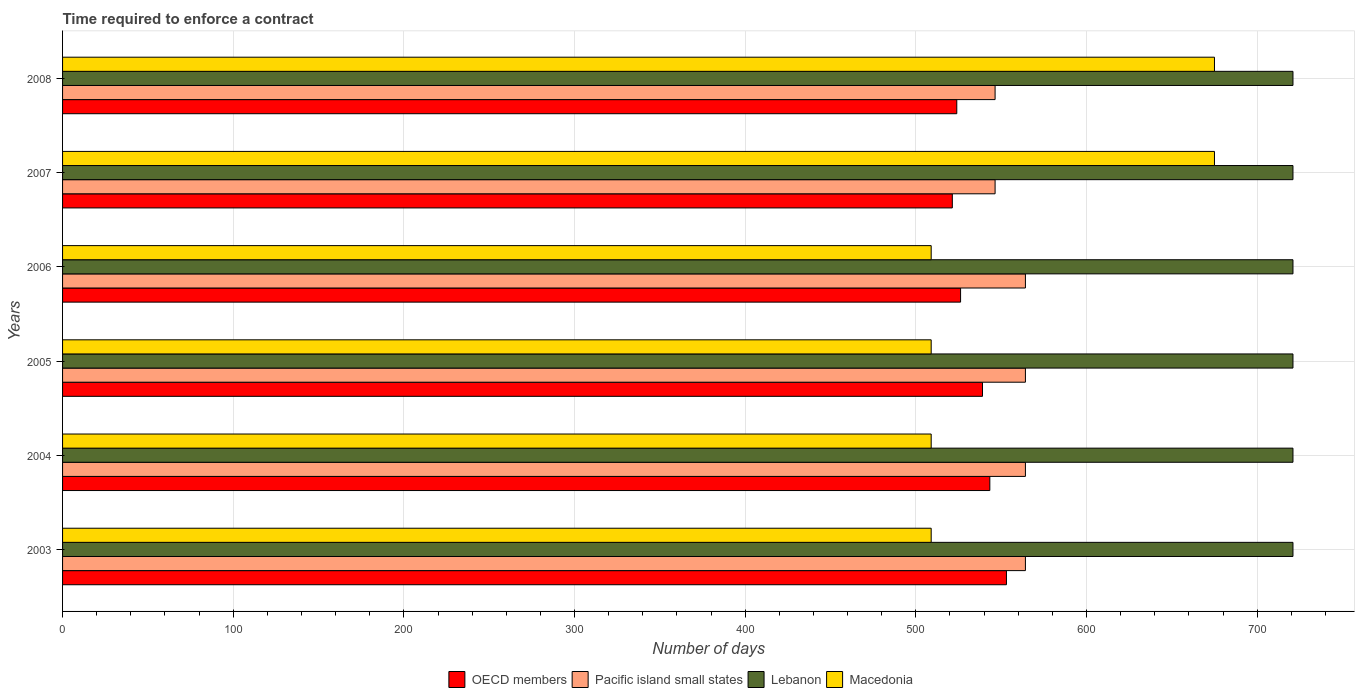How many different coloured bars are there?
Provide a succinct answer. 4. How many groups of bars are there?
Provide a succinct answer. 6. What is the label of the 3rd group of bars from the top?
Your answer should be very brief. 2006. In how many cases, is the number of bars for a given year not equal to the number of legend labels?
Keep it short and to the point. 0. What is the number of days required to enforce a contract in Pacific island small states in 2006?
Offer a very short reply. 564.22. Across all years, what is the maximum number of days required to enforce a contract in OECD members?
Offer a terse response. 553.1. Across all years, what is the minimum number of days required to enforce a contract in Lebanon?
Your response must be concise. 721. In which year was the number of days required to enforce a contract in Macedonia maximum?
Your response must be concise. 2007. In which year was the number of days required to enforce a contract in Pacific island small states minimum?
Offer a terse response. 2007. What is the total number of days required to enforce a contract in OECD members in the graph?
Ensure brevity in your answer.  3207.15. What is the difference between the number of days required to enforce a contract in Lebanon in 2007 and that in 2008?
Offer a very short reply. 0. What is the average number of days required to enforce a contract in Pacific island small states per year?
Provide a short and direct response. 558.3. In the year 2005, what is the difference between the number of days required to enforce a contract in Pacific island small states and number of days required to enforce a contract in Macedonia?
Make the answer very short. 55.22. What is the difference between the highest and the lowest number of days required to enforce a contract in Pacific island small states?
Keep it short and to the point. 17.78. Is it the case that in every year, the sum of the number of days required to enforce a contract in OECD members and number of days required to enforce a contract in Pacific island small states is greater than the sum of number of days required to enforce a contract in Lebanon and number of days required to enforce a contract in Macedonia?
Give a very brief answer. No. What does the 4th bar from the top in 2005 represents?
Your answer should be compact. OECD members. What does the 1st bar from the bottom in 2006 represents?
Provide a short and direct response. OECD members. Is it the case that in every year, the sum of the number of days required to enforce a contract in OECD members and number of days required to enforce a contract in Pacific island small states is greater than the number of days required to enforce a contract in Lebanon?
Keep it short and to the point. Yes. How many bars are there?
Your response must be concise. 24. Are all the bars in the graph horizontal?
Keep it short and to the point. Yes. What is the difference between two consecutive major ticks on the X-axis?
Make the answer very short. 100. Are the values on the major ticks of X-axis written in scientific E-notation?
Your answer should be very brief. No. Does the graph contain any zero values?
Provide a succinct answer. No. Where does the legend appear in the graph?
Keep it short and to the point. Bottom center. What is the title of the graph?
Offer a terse response. Time required to enforce a contract. What is the label or title of the X-axis?
Offer a terse response. Number of days. What is the label or title of the Y-axis?
Provide a short and direct response. Years. What is the Number of days in OECD members in 2003?
Your response must be concise. 553.1. What is the Number of days of Pacific island small states in 2003?
Offer a very short reply. 564.22. What is the Number of days in Lebanon in 2003?
Your answer should be very brief. 721. What is the Number of days of Macedonia in 2003?
Offer a terse response. 509. What is the Number of days of OECD members in 2004?
Keep it short and to the point. 543.37. What is the Number of days in Pacific island small states in 2004?
Provide a succinct answer. 564.22. What is the Number of days of Lebanon in 2004?
Keep it short and to the point. 721. What is the Number of days of Macedonia in 2004?
Ensure brevity in your answer.  509. What is the Number of days in OECD members in 2005?
Your response must be concise. 539.07. What is the Number of days in Pacific island small states in 2005?
Your answer should be compact. 564.22. What is the Number of days of Lebanon in 2005?
Give a very brief answer. 721. What is the Number of days of Macedonia in 2005?
Your response must be concise. 509. What is the Number of days of OECD members in 2006?
Keep it short and to the point. 526.23. What is the Number of days of Pacific island small states in 2006?
Your answer should be compact. 564.22. What is the Number of days of Lebanon in 2006?
Keep it short and to the point. 721. What is the Number of days in Macedonia in 2006?
Offer a terse response. 509. What is the Number of days in OECD members in 2007?
Give a very brief answer. 521.39. What is the Number of days in Pacific island small states in 2007?
Provide a succinct answer. 546.44. What is the Number of days of Lebanon in 2007?
Provide a succinct answer. 721. What is the Number of days in Macedonia in 2007?
Offer a terse response. 675. What is the Number of days in OECD members in 2008?
Your answer should be very brief. 524. What is the Number of days of Pacific island small states in 2008?
Offer a very short reply. 546.44. What is the Number of days in Lebanon in 2008?
Your response must be concise. 721. What is the Number of days in Macedonia in 2008?
Offer a terse response. 675. Across all years, what is the maximum Number of days of OECD members?
Offer a terse response. 553.1. Across all years, what is the maximum Number of days in Pacific island small states?
Ensure brevity in your answer.  564.22. Across all years, what is the maximum Number of days of Lebanon?
Provide a short and direct response. 721. Across all years, what is the maximum Number of days in Macedonia?
Offer a very short reply. 675. Across all years, what is the minimum Number of days of OECD members?
Keep it short and to the point. 521.39. Across all years, what is the minimum Number of days of Pacific island small states?
Give a very brief answer. 546.44. Across all years, what is the minimum Number of days of Lebanon?
Offer a terse response. 721. Across all years, what is the minimum Number of days of Macedonia?
Your response must be concise. 509. What is the total Number of days of OECD members in the graph?
Provide a succinct answer. 3207.15. What is the total Number of days of Pacific island small states in the graph?
Offer a very short reply. 3349.78. What is the total Number of days in Lebanon in the graph?
Make the answer very short. 4326. What is the total Number of days in Macedonia in the graph?
Make the answer very short. 3386. What is the difference between the Number of days of OECD members in 2003 and that in 2004?
Your answer should be very brief. 9.74. What is the difference between the Number of days in Pacific island small states in 2003 and that in 2004?
Provide a succinct answer. 0. What is the difference between the Number of days in Lebanon in 2003 and that in 2004?
Your response must be concise. 0. What is the difference between the Number of days of OECD members in 2003 and that in 2005?
Offer a very short reply. 14.04. What is the difference between the Number of days in Macedonia in 2003 and that in 2005?
Ensure brevity in your answer.  0. What is the difference between the Number of days of OECD members in 2003 and that in 2006?
Offer a terse response. 26.88. What is the difference between the Number of days in Pacific island small states in 2003 and that in 2006?
Provide a short and direct response. 0. What is the difference between the Number of days of Macedonia in 2003 and that in 2006?
Your answer should be very brief. 0. What is the difference between the Number of days in OECD members in 2003 and that in 2007?
Give a very brief answer. 31.72. What is the difference between the Number of days in Pacific island small states in 2003 and that in 2007?
Give a very brief answer. 17.78. What is the difference between the Number of days of Macedonia in 2003 and that in 2007?
Provide a succinct answer. -166. What is the difference between the Number of days of OECD members in 2003 and that in 2008?
Offer a terse response. 29.1. What is the difference between the Number of days in Pacific island small states in 2003 and that in 2008?
Your answer should be very brief. 17.78. What is the difference between the Number of days of Macedonia in 2003 and that in 2008?
Offer a terse response. -166. What is the difference between the Number of days of Macedonia in 2004 and that in 2005?
Make the answer very short. 0. What is the difference between the Number of days in OECD members in 2004 and that in 2006?
Offer a very short reply. 17.14. What is the difference between the Number of days of Pacific island small states in 2004 and that in 2006?
Keep it short and to the point. 0. What is the difference between the Number of days in OECD members in 2004 and that in 2007?
Your answer should be compact. 21.98. What is the difference between the Number of days of Pacific island small states in 2004 and that in 2007?
Ensure brevity in your answer.  17.78. What is the difference between the Number of days of Macedonia in 2004 and that in 2007?
Give a very brief answer. -166. What is the difference between the Number of days of OECD members in 2004 and that in 2008?
Give a very brief answer. 19.37. What is the difference between the Number of days in Pacific island small states in 2004 and that in 2008?
Give a very brief answer. 17.78. What is the difference between the Number of days of Lebanon in 2004 and that in 2008?
Provide a short and direct response. 0. What is the difference between the Number of days of Macedonia in 2004 and that in 2008?
Ensure brevity in your answer.  -166. What is the difference between the Number of days in OECD members in 2005 and that in 2006?
Offer a very short reply. 12.84. What is the difference between the Number of days of OECD members in 2005 and that in 2007?
Make the answer very short. 17.68. What is the difference between the Number of days in Pacific island small states in 2005 and that in 2007?
Ensure brevity in your answer.  17.78. What is the difference between the Number of days in Macedonia in 2005 and that in 2007?
Keep it short and to the point. -166. What is the difference between the Number of days of OECD members in 2005 and that in 2008?
Keep it short and to the point. 15.07. What is the difference between the Number of days of Pacific island small states in 2005 and that in 2008?
Make the answer very short. 17.78. What is the difference between the Number of days in Macedonia in 2005 and that in 2008?
Offer a terse response. -166. What is the difference between the Number of days in OECD members in 2006 and that in 2007?
Offer a very short reply. 4.84. What is the difference between the Number of days in Pacific island small states in 2006 and that in 2007?
Give a very brief answer. 17.78. What is the difference between the Number of days of Lebanon in 2006 and that in 2007?
Your answer should be compact. 0. What is the difference between the Number of days in Macedonia in 2006 and that in 2007?
Provide a succinct answer. -166. What is the difference between the Number of days in OECD members in 2006 and that in 2008?
Offer a very short reply. 2.23. What is the difference between the Number of days of Pacific island small states in 2006 and that in 2008?
Keep it short and to the point. 17.78. What is the difference between the Number of days in Lebanon in 2006 and that in 2008?
Offer a very short reply. 0. What is the difference between the Number of days of Macedonia in 2006 and that in 2008?
Provide a succinct answer. -166. What is the difference between the Number of days in OECD members in 2007 and that in 2008?
Give a very brief answer. -2.61. What is the difference between the Number of days of Pacific island small states in 2007 and that in 2008?
Offer a terse response. 0. What is the difference between the Number of days in Macedonia in 2007 and that in 2008?
Make the answer very short. 0. What is the difference between the Number of days in OECD members in 2003 and the Number of days in Pacific island small states in 2004?
Provide a succinct answer. -11.12. What is the difference between the Number of days in OECD members in 2003 and the Number of days in Lebanon in 2004?
Your answer should be compact. -167.9. What is the difference between the Number of days of OECD members in 2003 and the Number of days of Macedonia in 2004?
Give a very brief answer. 44.1. What is the difference between the Number of days of Pacific island small states in 2003 and the Number of days of Lebanon in 2004?
Ensure brevity in your answer.  -156.78. What is the difference between the Number of days in Pacific island small states in 2003 and the Number of days in Macedonia in 2004?
Make the answer very short. 55.22. What is the difference between the Number of days in Lebanon in 2003 and the Number of days in Macedonia in 2004?
Your answer should be very brief. 212. What is the difference between the Number of days in OECD members in 2003 and the Number of days in Pacific island small states in 2005?
Your response must be concise. -11.12. What is the difference between the Number of days of OECD members in 2003 and the Number of days of Lebanon in 2005?
Keep it short and to the point. -167.9. What is the difference between the Number of days of OECD members in 2003 and the Number of days of Macedonia in 2005?
Offer a terse response. 44.1. What is the difference between the Number of days of Pacific island small states in 2003 and the Number of days of Lebanon in 2005?
Provide a short and direct response. -156.78. What is the difference between the Number of days of Pacific island small states in 2003 and the Number of days of Macedonia in 2005?
Ensure brevity in your answer.  55.22. What is the difference between the Number of days in Lebanon in 2003 and the Number of days in Macedonia in 2005?
Your response must be concise. 212. What is the difference between the Number of days of OECD members in 2003 and the Number of days of Pacific island small states in 2006?
Make the answer very short. -11.12. What is the difference between the Number of days of OECD members in 2003 and the Number of days of Lebanon in 2006?
Make the answer very short. -167.9. What is the difference between the Number of days of OECD members in 2003 and the Number of days of Macedonia in 2006?
Offer a terse response. 44.1. What is the difference between the Number of days in Pacific island small states in 2003 and the Number of days in Lebanon in 2006?
Offer a very short reply. -156.78. What is the difference between the Number of days of Pacific island small states in 2003 and the Number of days of Macedonia in 2006?
Provide a short and direct response. 55.22. What is the difference between the Number of days in Lebanon in 2003 and the Number of days in Macedonia in 2006?
Provide a short and direct response. 212. What is the difference between the Number of days of OECD members in 2003 and the Number of days of Pacific island small states in 2007?
Ensure brevity in your answer.  6.66. What is the difference between the Number of days in OECD members in 2003 and the Number of days in Lebanon in 2007?
Your answer should be compact. -167.9. What is the difference between the Number of days in OECD members in 2003 and the Number of days in Macedonia in 2007?
Your answer should be compact. -121.9. What is the difference between the Number of days of Pacific island small states in 2003 and the Number of days of Lebanon in 2007?
Provide a short and direct response. -156.78. What is the difference between the Number of days of Pacific island small states in 2003 and the Number of days of Macedonia in 2007?
Keep it short and to the point. -110.78. What is the difference between the Number of days of OECD members in 2003 and the Number of days of Pacific island small states in 2008?
Provide a succinct answer. 6.66. What is the difference between the Number of days of OECD members in 2003 and the Number of days of Lebanon in 2008?
Offer a very short reply. -167.9. What is the difference between the Number of days of OECD members in 2003 and the Number of days of Macedonia in 2008?
Offer a terse response. -121.9. What is the difference between the Number of days of Pacific island small states in 2003 and the Number of days of Lebanon in 2008?
Your response must be concise. -156.78. What is the difference between the Number of days in Pacific island small states in 2003 and the Number of days in Macedonia in 2008?
Offer a terse response. -110.78. What is the difference between the Number of days of OECD members in 2004 and the Number of days of Pacific island small states in 2005?
Ensure brevity in your answer.  -20.86. What is the difference between the Number of days in OECD members in 2004 and the Number of days in Lebanon in 2005?
Make the answer very short. -177.63. What is the difference between the Number of days of OECD members in 2004 and the Number of days of Macedonia in 2005?
Your answer should be very brief. 34.37. What is the difference between the Number of days of Pacific island small states in 2004 and the Number of days of Lebanon in 2005?
Offer a terse response. -156.78. What is the difference between the Number of days of Pacific island small states in 2004 and the Number of days of Macedonia in 2005?
Offer a terse response. 55.22. What is the difference between the Number of days in Lebanon in 2004 and the Number of days in Macedonia in 2005?
Provide a succinct answer. 212. What is the difference between the Number of days in OECD members in 2004 and the Number of days in Pacific island small states in 2006?
Ensure brevity in your answer.  -20.86. What is the difference between the Number of days in OECD members in 2004 and the Number of days in Lebanon in 2006?
Your answer should be compact. -177.63. What is the difference between the Number of days of OECD members in 2004 and the Number of days of Macedonia in 2006?
Provide a short and direct response. 34.37. What is the difference between the Number of days of Pacific island small states in 2004 and the Number of days of Lebanon in 2006?
Make the answer very short. -156.78. What is the difference between the Number of days in Pacific island small states in 2004 and the Number of days in Macedonia in 2006?
Provide a short and direct response. 55.22. What is the difference between the Number of days of Lebanon in 2004 and the Number of days of Macedonia in 2006?
Your answer should be compact. 212. What is the difference between the Number of days in OECD members in 2004 and the Number of days in Pacific island small states in 2007?
Keep it short and to the point. -3.08. What is the difference between the Number of days in OECD members in 2004 and the Number of days in Lebanon in 2007?
Ensure brevity in your answer.  -177.63. What is the difference between the Number of days of OECD members in 2004 and the Number of days of Macedonia in 2007?
Make the answer very short. -131.63. What is the difference between the Number of days of Pacific island small states in 2004 and the Number of days of Lebanon in 2007?
Make the answer very short. -156.78. What is the difference between the Number of days of Pacific island small states in 2004 and the Number of days of Macedonia in 2007?
Offer a very short reply. -110.78. What is the difference between the Number of days of Lebanon in 2004 and the Number of days of Macedonia in 2007?
Your answer should be very brief. 46. What is the difference between the Number of days in OECD members in 2004 and the Number of days in Pacific island small states in 2008?
Keep it short and to the point. -3.08. What is the difference between the Number of days of OECD members in 2004 and the Number of days of Lebanon in 2008?
Provide a succinct answer. -177.63. What is the difference between the Number of days in OECD members in 2004 and the Number of days in Macedonia in 2008?
Offer a terse response. -131.63. What is the difference between the Number of days of Pacific island small states in 2004 and the Number of days of Lebanon in 2008?
Your answer should be very brief. -156.78. What is the difference between the Number of days of Pacific island small states in 2004 and the Number of days of Macedonia in 2008?
Your answer should be very brief. -110.78. What is the difference between the Number of days of OECD members in 2005 and the Number of days of Pacific island small states in 2006?
Provide a succinct answer. -25.16. What is the difference between the Number of days of OECD members in 2005 and the Number of days of Lebanon in 2006?
Provide a short and direct response. -181.93. What is the difference between the Number of days of OECD members in 2005 and the Number of days of Macedonia in 2006?
Provide a succinct answer. 30.07. What is the difference between the Number of days in Pacific island small states in 2005 and the Number of days in Lebanon in 2006?
Keep it short and to the point. -156.78. What is the difference between the Number of days in Pacific island small states in 2005 and the Number of days in Macedonia in 2006?
Give a very brief answer. 55.22. What is the difference between the Number of days in Lebanon in 2005 and the Number of days in Macedonia in 2006?
Your response must be concise. 212. What is the difference between the Number of days in OECD members in 2005 and the Number of days in Pacific island small states in 2007?
Provide a short and direct response. -7.38. What is the difference between the Number of days in OECD members in 2005 and the Number of days in Lebanon in 2007?
Your response must be concise. -181.93. What is the difference between the Number of days in OECD members in 2005 and the Number of days in Macedonia in 2007?
Offer a terse response. -135.93. What is the difference between the Number of days in Pacific island small states in 2005 and the Number of days in Lebanon in 2007?
Provide a short and direct response. -156.78. What is the difference between the Number of days in Pacific island small states in 2005 and the Number of days in Macedonia in 2007?
Give a very brief answer. -110.78. What is the difference between the Number of days of OECD members in 2005 and the Number of days of Pacific island small states in 2008?
Keep it short and to the point. -7.38. What is the difference between the Number of days of OECD members in 2005 and the Number of days of Lebanon in 2008?
Your answer should be compact. -181.93. What is the difference between the Number of days in OECD members in 2005 and the Number of days in Macedonia in 2008?
Ensure brevity in your answer.  -135.93. What is the difference between the Number of days of Pacific island small states in 2005 and the Number of days of Lebanon in 2008?
Keep it short and to the point. -156.78. What is the difference between the Number of days of Pacific island small states in 2005 and the Number of days of Macedonia in 2008?
Provide a short and direct response. -110.78. What is the difference between the Number of days of Lebanon in 2005 and the Number of days of Macedonia in 2008?
Provide a short and direct response. 46. What is the difference between the Number of days in OECD members in 2006 and the Number of days in Pacific island small states in 2007?
Offer a terse response. -20.22. What is the difference between the Number of days of OECD members in 2006 and the Number of days of Lebanon in 2007?
Provide a short and direct response. -194.77. What is the difference between the Number of days in OECD members in 2006 and the Number of days in Macedonia in 2007?
Provide a short and direct response. -148.77. What is the difference between the Number of days of Pacific island small states in 2006 and the Number of days of Lebanon in 2007?
Offer a very short reply. -156.78. What is the difference between the Number of days of Pacific island small states in 2006 and the Number of days of Macedonia in 2007?
Your answer should be compact. -110.78. What is the difference between the Number of days of Lebanon in 2006 and the Number of days of Macedonia in 2007?
Give a very brief answer. 46. What is the difference between the Number of days of OECD members in 2006 and the Number of days of Pacific island small states in 2008?
Provide a succinct answer. -20.22. What is the difference between the Number of days in OECD members in 2006 and the Number of days in Lebanon in 2008?
Your response must be concise. -194.77. What is the difference between the Number of days in OECD members in 2006 and the Number of days in Macedonia in 2008?
Offer a terse response. -148.77. What is the difference between the Number of days in Pacific island small states in 2006 and the Number of days in Lebanon in 2008?
Provide a short and direct response. -156.78. What is the difference between the Number of days of Pacific island small states in 2006 and the Number of days of Macedonia in 2008?
Ensure brevity in your answer.  -110.78. What is the difference between the Number of days in OECD members in 2007 and the Number of days in Pacific island small states in 2008?
Your answer should be very brief. -25.06. What is the difference between the Number of days of OECD members in 2007 and the Number of days of Lebanon in 2008?
Provide a short and direct response. -199.61. What is the difference between the Number of days in OECD members in 2007 and the Number of days in Macedonia in 2008?
Offer a terse response. -153.61. What is the difference between the Number of days in Pacific island small states in 2007 and the Number of days in Lebanon in 2008?
Your response must be concise. -174.56. What is the difference between the Number of days in Pacific island small states in 2007 and the Number of days in Macedonia in 2008?
Offer a very short reply. -128.56. What is the difference between the Number of days in Lebanon in 2007 and the Number of days in Macedonia in 2008?
Make the answer very short. 46. What is the average Number of days in OECD members per year?
Your answer should be very brief. 534.52. What is the average Number of days of Pacific island small states per year?
Make the answer very short. 558.3. What is the average Number of days in Lebanon per year?
Offer a very short reply. 721. What is the average Number of days in Macedonia per year?
Provide a short and direct response. 564.33. In the year 2003, what is the difference between the Number of days of OECD members and Number of days of Pacific island small states?
Your answer should be compact. -11.12. In the year 2003, what is the difference between the Number of days of OECD members and Number of days of Lebanon?
Make the answer very short. -167.9. In the year 2003, what is the difference between the Number of days of OECD members and Number of days of Macedonia?
Offer a very short reply. 44.1. In the year 2003, what is the difference between the Number of days in Pacific island small states and Number of days in Lebanon?
Your answer should be compact. -156.78. In the year 2003, what is the difference between the Number of days in Pacific island small states and Number of days in Macedonia?
Provide a succinct answer. 55.22. In the year 2003, what is the difference between the Number of days of Lebanon and Number of days of Macedonia?
Give a very brief answer. 212. In the year 2004, what is the difference between the Number of days in OECD members and Number of days in Pacific island small states?
Your answer should be very brief. -20.86. In the year 2004, what is the difference between the Number of days in OECD members and Number of days in Lebanon?
Offer a terse response. -177.63. In the year 2004, what is the difference between the Number of days of OECD members and Number of days of Macedonia?
Your answer should be compact. 34.37. In the year 2004, what is the difference between the Number of days in Pacific island small states and Number of days in Lebanon?
Your response must be concise. -156.78. In the year 2004, what is the difference between the Number of days in Pacific island small states and Number of days in Macedonia?
Give a very brief answer. 55.22. In the year 2004, what is the difference between the Number of days in Lebanon and Number of days in Macedonia?
Keep it short and to the point. 212. In the year 2005, what is the difference between the Number of days in OECD members and Number of days in Pacific island small states?
Give a very brief answer. -25.16. In the year 2005, what is the difference between the Number of days of OECD members and Number of days of Lebanon?
Ensure brevity in your answer.  -181.93. In the year 2005, what is the difference between the Number of days in OECD members and Number of days in Macedonia?
Your answer should be very brief. 30.07. In the year 2005, what is the difference between the Number of days of Pacific island small states and Number of days of Lebanon?
Give a very brief answer. -156.78. In the year 2005, what is the difference between the Number of days of Pacific island small states and Number of days of Macedonia?
Ensure brevity in your answer.  55.22. In the year 2005, what is the difference between the Number of days in Lebanon and Number of days in Macedonia?
Provide a succinct answer. 212. In the year 2006, what is the difference between the Number of days of OECD members and Number of days of Pacific island small states?
Your answer should be compact. -38. In the year 2006, what is the difference between the Number of days of OECD members and Number of days of Lebanon?
Give a very brief answer. -194.77. In the year 2006, what is the difference between the Number of days in OECD members and Number of days in Macedonia?
Your answer should be very brief. 17.23. In the year 2006, what is the difference between the Number of days of Pacific island small states and Number of days of Lebanon?
Keep it short and to the point. -156.78. In the year 2006, what is the difference between the Number of days in Pacific island small states and Number of days in Macedonia?
Provide a succinct answer. 55.22. In the year 2006, what is the difference between the Number of days of Lebanon and Number of days of Macedonia?
Offer a terse response. 212. In the year 2007, what is the difference between the Number of days in OECD members and Number of days in Pacific island small states?
Offer a terse response. -25.06. In the year 2007, what is the difference between the Number of days in OECD members and Number of days in Lebanon?
Provide a succinct answer. -199.61. In the year 2007, what is the difference between the Number of days of OECD members and Number of days of Macedonia?
Your answer should be very brief. -153.61. In the year 2007, what is the difference between the Number of days of Pacific island small states and Number of days of Lebanon?
Give a very brief answer. -174.56. In the year 2007, what is the difference between the Number of days in Pacific island small states and Number of days in Macedonia?
Offer a terse response. -128.56. In the year 2007, what is the difference between the Number of days of Lebanon and Number of days of Macedonia?
Make the answer very short. 46. In the year 2008, what is the difference between the Number of days of OECD members and Number of days of Pacific island small states?
Give a very brief answer. -22.44. In the year 2008, what is the difference between the Number of days in OECD members and Number of days in Lebanon?
Offer a terse response. -197. In the year 2008, what is the difference between the Number of days of OECD members and Number of days of Macedonia?
Ensure brevity in your answer.  -151. In the year 2008, what is the difference between the Number of days in Pacific island small states and Number of days in Lebanon?
Offer a terse response. -174.56. In the year 2008, what is the difference between the Number of days of Pacific island small states and Number of days of Macedonia?
Offer a very short reply. -128.56. In the year 2008, what is the difference between the Number of days of Lebanon and Number of days of Macedonia?
Your answer should be compact. 46. What is the ratio of the Number of days of OECD members in 2003 to that in 2004?
Make the answer very short. 1.02. What is the ratio of the Number of days in Pacific island small states in 2003 to that in 2004?
Give a very brief answer. 1. What is the ratio of the Number of days of Lebanon in 2003 to that in 2004?
Provide a short and direct response. 1. What is the ratio of the Number of days of Macedonia in 2003 to that in 2004?
Give a very brief answer. 1. What is the ratio of the Number of days in OECD members in 2003 to that in 2005?
Make the answer very short. 1.03. What is the ratio of the Number of days of Macedonia in 2003 to that in 2005?
Make the answer very short. 1. What is the ratio of the Number of days of OECD members in 2003 to that in 2006?
Your answer should be very brief. 1.05. What is the ratio of the Number of days of Macedonia in 2003 to that in 2006?
Your answer should be compact. 1. What is the ratio of the Number of days in OECD members in 2003 to that in 2007?
Ensure brevity in your answer.  1.06. What is the ratio of the Number of days in Pacific island small states in 2003 to that in 2007?
Your answer should be compact. 1.03. What is the ratio of the Number of days in Lebanon in 2003 to that in 2007?
Your response must be concise. 1. What is the ratio of the Number of days of Macedonia in 2003 to that in 2007?
Give a very brief answer. 0.75. What is the ratio of the Number of days in OECD members in 2003 to that in 2008?
Your answer should be very brief. 1.06. What is the ratio of the Number of days of Pacific island small states in 2003 to that in 2008?
Keep it short and to the point. 1.03. What is the ratio of the Number of days in Macedonia in 2003 to that in 2008?
Your response must be concise. 0.75. What is the ratio of the Number of days in Pacific island small states in 2004 to that in 2005?
Make the answer very short. 1. What is the ratio of the Number of days in OECD members in 2004 to that in 2006?
Your response must be concise. 1.03. What is the ratio of the Number of days in OECD members in 2004 to that in 2007?
Your answer should be compact. 1.04. What is the ratio of the Number of days in Pacific island small states in 2004 to that in 2007?
Ensure brevity in your answer.  1.03. What is the ratio of the Number of days of Macedonia in 2004 to that in 2007?
Provide a succinct answer. 0.75. What is the ratio of the Number of days of Pacific island small states in 2004 to that in 2008?
Keep it short and to the point. 1.03. What is the ratio of the Number of days in Lebanon in 2004 to that in 2008?
Offer a terse response. 1. What is the ratio of the Number of days in Macedonia in 2004 to that in 2008?
Your answer should be very brief. 0.75. What is the ratio of the Number of days in OECD members in 2005 to that in 2006?
Keep it short and to the point. 1.02. What is the ratio of the Number of days in Pacific island small states in 2005 to that in 2006?
Your answer should be very brief. 1. What is the ratio of the Number of days in OECD members in 2005 to that in 2007?
Provide a short and direct response. 1.03. What is the ratio of the Number of days in Pacific island small states in 2005 to that in 2007?
Offer a very short reply. 1.03. What is the ratio of the Number of days of Macedonia in 2005 to that in 2007?
Your answer should be very brief. 0.75. What is the ratio of the Number of days of OECD members in 2005 to that in 2008?
Your answer should be very brief. 1.03. What is the ratio of the Number of days in Pacific island small states in 2005 to that in 2008?
Your answer should be very brief. 1.03. What is the ratio of the Number of days in Macedonia in 2005 to that in 2008?
Your response must be concise. 0.75. What is the ratio of the Number of days of OECD members in 2006 to that in 2007?
Your answer should be compact. 1.01. What is the ratio of the Number of days in Pacific island small states in 2006 to that in 2007?
Offer a terse response. 1.03. What is the ratio of the Number of days of Macedonia in 2006 to that in 2007?
Ensure brevity in your answer.  0.75. What is the ratio of the Number of days in OECD members in 2006 to that in 2008?
Your response must be concise. 1. What is the ratio of the Number of days of Pacific island small states in 2006 to that in 2008?
Your response must be concise. 1.03. What is the ratio of the Number of days of Lebanon in 2006 to that in 2008?
Your answer should be very brief. 1. What is the ratio of the Number of days of Macedonia in 2006 to that in 2008?
Offer a very short reply. 0.75. What is the ratio of the Number of days of OECD members in 2007 to that in 2008?
Offer a terse response. 0.99. What is the ratio of the Number of days of Lebanon in 2007 to that in 2008?
Provide a short and direct response. 1. What is the difference between the highest and the second highest Number of days in OECD members?
Make the answer very short. 9.74. What is the difference between the highest and the second highest Number of days of Macedonia?
Your response must be concise. 0. What is the difference between the highest and the lowest Number of days in OECD members?
Offer a terse response. 31.72. What is the difference between the highest and the lowest Number of days in Pacific island small states?
Your response must be concise. 17.78. What is the difference between the highest and the lowest Number of days of Macedonia?
Your answer should be very brief. 166. 